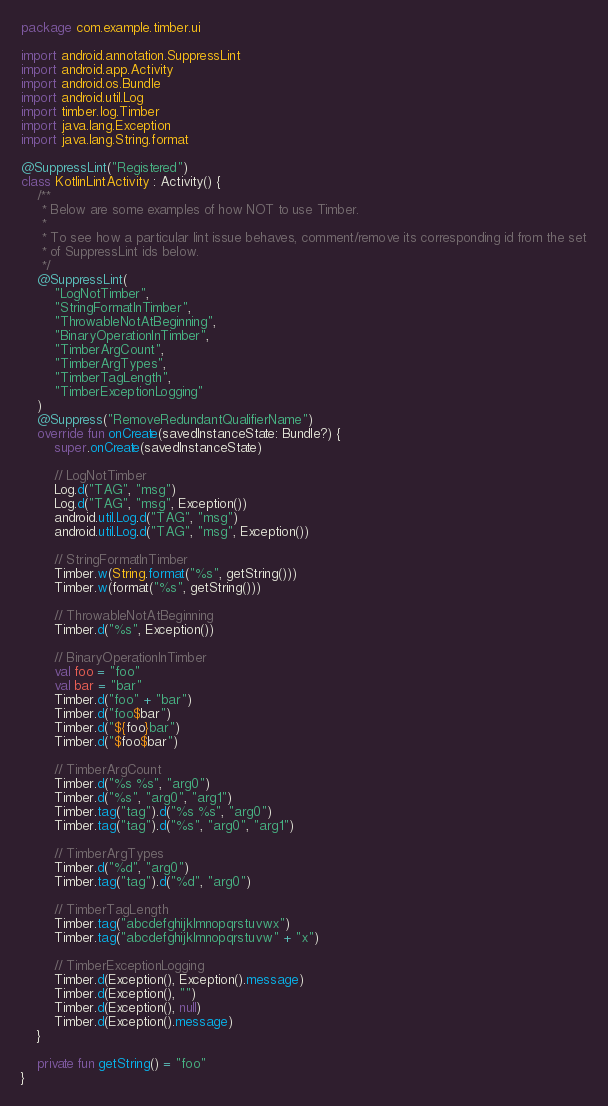<code> <loc_0><loc_0><loc_500><loc_500><_Kotlin_>package com.example.timber.ui

import android.annotation.SuppressLint
import android.app.Activity
import android.os.Bundle
import android.util.Log
import timber.log.Timber
import java.lang.Exception
import java.lang.String.format

@SuppressLint("Registered")
class KotlinLintActivity : Activity() {
    /**
     * Below are some examples of how NOT to use Timber.
     *
     * To see how a particular lint issue behaves, comment/remove its corresponding id from the set
     * of SuppressLint ids below.
     */
    @SuppressLint(
        "LogNotTimber",
        "StringFormatInTimber",
        "ThrowableNotAtBeginning",
        "BinaryOperationInTimber",
        "TimberArgCount",
        "TimberArgTypes",
        "TimberTagLength",
        "TimberExceptionLogging"
    )
    @Suppress("RemoveRedundantQualifierName")
    override fun onCreate(savedInstanceState: Bundle?) {
        super.onCreate(savedInstanceState)

        // LogNotTimber
        Log.d("TAG", "msg")
        Log.d("TAG", "msg", Exception())
        android.util.Log.d("TAG", "msg")
        android.util.Log.d("TAG", "msg", Exception())

        // StringFormatInTimber
        Timber.w(String.format("%s", getString()))
        Timber.w(format("%s", getString()))

        // ThrowableNotAtBeginning
        Timber.d("%s", Exception())

        // BinaryOperationInTimber
        val foo = "foo"
        val bar = "bar"
        Timber.d("foo" + "bar")
        Timber.d("foo$bar")
        Timber.d("${foo}bar")
        Timber.d("$foo$bar")

        // TimberArgCount
        Timber.d("%s %s", "arg0")
        Timber.d("%s", "arg0", "arg1")
        Timber.tag("tag").d("%s %s", "arg0")
        Timber.tag("tag").d("%s", "arg0", "arg1")

        // TimberArgTypes
        Timber.d("%d", "arg0")
        Timber.tag("tag").d("%d", "arg0")

        // TimberTagLength
        Timber.tag("abcdefghijklmnopqrstuvwx")
        Timber.tag("abcdefghijklmnopqrstuvw" + "x")

        // TimberExceptionLogging
        Timber.d(Exception(), Exception().message)
        Timber.d(Exception(), "")
        Timber.d(Exception(), null)
        Timber.d(Exception().message)
    }

    private fun getString() = "foo"
}</code> 